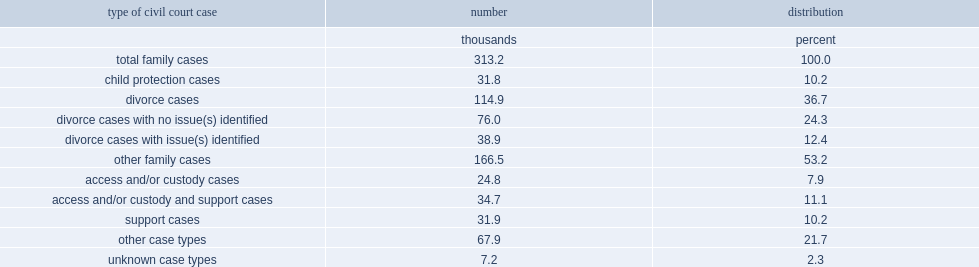How many thousands were family cases among civil court cases according to the 2013/2014 civil court survey? 313.2. How many percentage points did family cases involved divorce cases among total family cases? 36.7. What is the percentage of divorce cases in 2013/2014 with no identified issues of access, custody or support among divorce cases? 0.661445. What is the percentage of divorce cases in 2013/2014 with no identified issues of access, custody or supportamong divorce cases? 0.338555. What is the percentage of other family cases related to access,custody and/or support? 0.291826. 